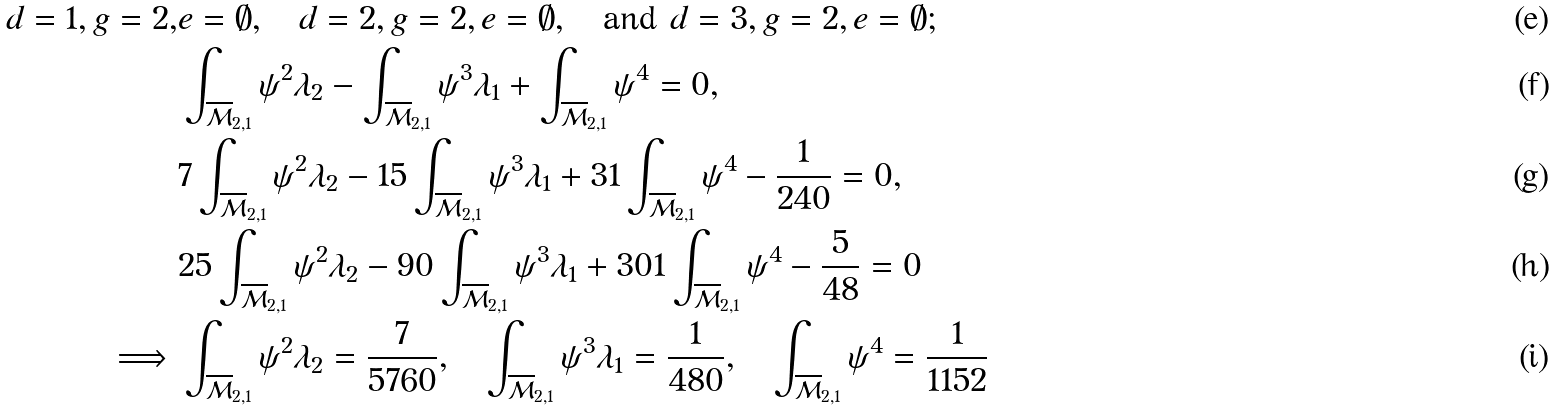<formula> <loc_0><loc_0><loc_500><loc_500>d = 1 , g = 2 , & e = \emptyset , \quad d = 2 , g = 2 , e = \emptyset , \quad \text {and } d = 3 , g = 2 , e = \emptyset ; \\ & \int _ { \overline { \mathcal { M } } _ { 2 , 1 } } \psi ^ { 2 } \lambda _ { 2 } - \int _ { \overline { \mathcal { M } } _ { 2 , 1 } } \psi ^ { 3 } \lambda _ { 1 } + \int _ { \overline { \mathcal { M } } _ { 2 , 1 } } \psi ^ { 4 } = 0 , \\ & 7 \int _ { \overline { \mathcal { M } } _ { 2 , 1 } } \psi ^ { 2 } \lambda _ { 2 } - 1 5 \int _ { \overline { \mathcal { M } } _ { 2 , 1 } } \psi ^ { 3 } \lambda _ { 1 } + 3 1 \int _ { \overline { \mathcal { M } } _ { 2 , 1 } } \psi ^ { 4 } - \frac { 1 } { 2 4 0 } = 0 , \\ & 2 5 \int _ { \overline { \mathcal { M } } _ { 2 , 1 } } \psi ^ { 2 } \lambda _ { 2 } - 9 0 \int _ { \overline { \mathcal { M } } _ { 2 , 1 } } \psi ^ { 3 } \lambda _ { 1 } + 3 0 1 \int _ { \overline { \mathcal { M } } _ { 2 , 1 } } \psi ^ { 4 } - \frac { 5 } { 4 8 } = 0 \\ \implies & \int _ { \overline { \mathcal { M } } _ { 2 , 1 } } \psi ^ { 2 } \lambda _ { 2 } = \frac { 7 } { 5 7 6 0 } , \quad \int _ { \overline { \mathcal { M } } _ { 2 , 1 } } \psi ^ { 3 } \lambda _ { 1 } = \frac { 1 } { 4 8 0 } , \quad \int _ { \overline { \mathcal { M } } _ { 2 , 1 } } \psi ^ { 4 } = \frac { 1 } { 1 1 5 2 }</formula> 